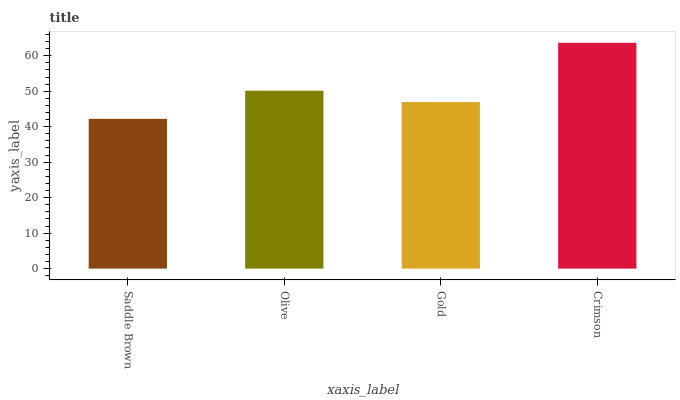Is Saddle Brown the minimum?
Answer yes or no. Yes. Is Crimson the maximum?
Answer yes or no. Yes. Is Olive the minimum?
Answer yes or no. No. Is Olive the maximum?
Answer yes or no. No. Is Olive greater than Saddle Brown?
Answer yes or no. Yes. Is Saddle Brown less than Olive?
Answer yes or no. Yes. Is Saddle Brown greater than Olive?
Answer yes or no. No. Is Olive less than Saddle Brown?
Answer yes or no. No. Is Olive the high median?
Answer yes or no. Yes. Is Gold the low median?
Answer yes or no. Yes. Is Crimson the high median?
Answer yes or no. No. Is Crimson the low median?
Answer yes or no. No. 